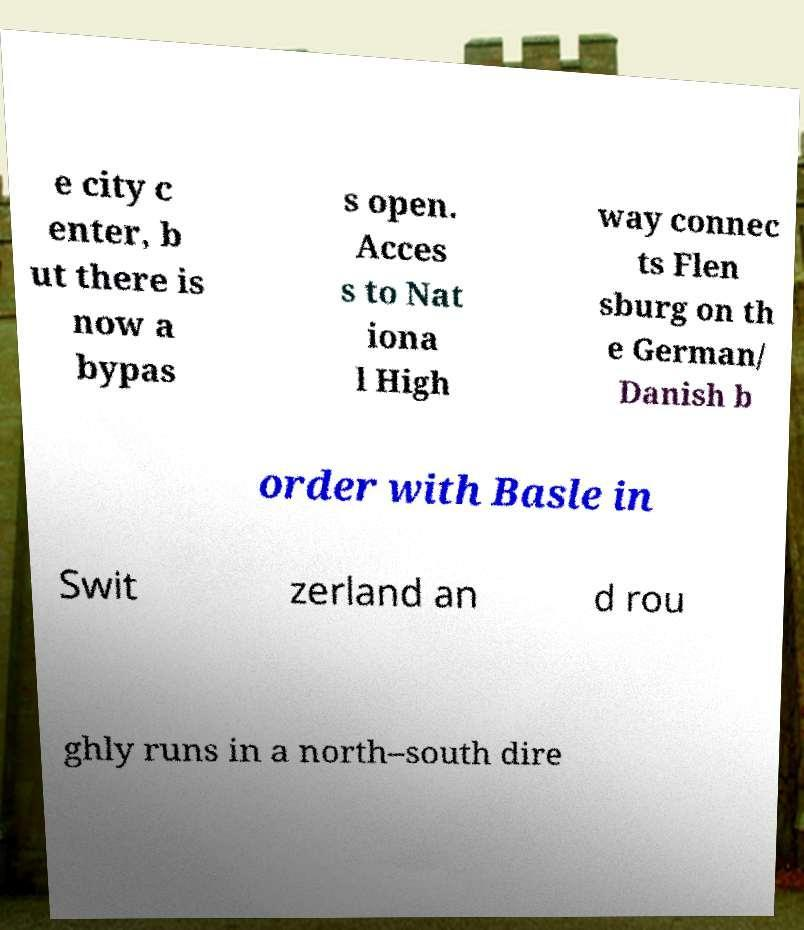Could you extract and type out the text from this image? e city c enter, b ut there is now a bypas s open. Acces s to Nat iona l High way connec ts Flen sburg on th e German/ Danish b order with Basle in Swit zerland an d rou ghly runs in a north–south dire 